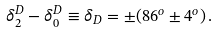Convert formula to latex. <formula><loc_0><loc_0><loc_500><loc_500>\delta _ { 2 } ^ { D } - \delta _ { 0 } ^ { D } \equiv \delta _ { D } = \pm ( 8 6 ^ { o } \pm 4 ^ { o } ) \, .</formula> 